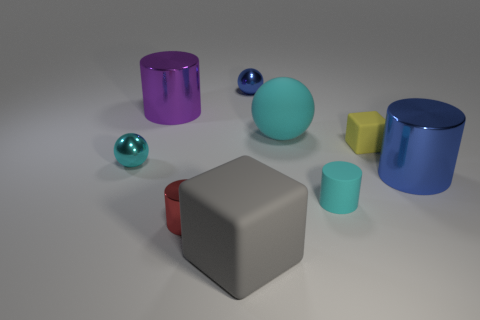Subtract all cyan cylinders. How many cylinders are left? 3 Subtract all blue balls. How many balls are left? 2 Add 1 small blue matte cylinders. How many objects exist? 10 Subtract all cubes. How many objects are left? 7 Subtract 1 blocks. How many blocks are left? 1 Subtract all green blocks. How many blue spheres are left? 1 Subtract all gray objects. Subtract all small matte objects. How many objects are left? 6 Add 4 small blue shiny things. How many small blue shiny things are left? 5 Add 8 big metallic things. How many big metallic things exist? 10 Subtract 0 red cubes. How many objects are left? 9 